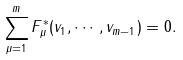Convert formula to latex. <formula><loc_0><loc_0><loc_500><loc_500>\sum _ { \mu = 1 } ^ { m } F _ { \mu } ^ { * } ( v _ { 1 } , \cdots , v _ { m - 1 } ) = 0 .</formula> 